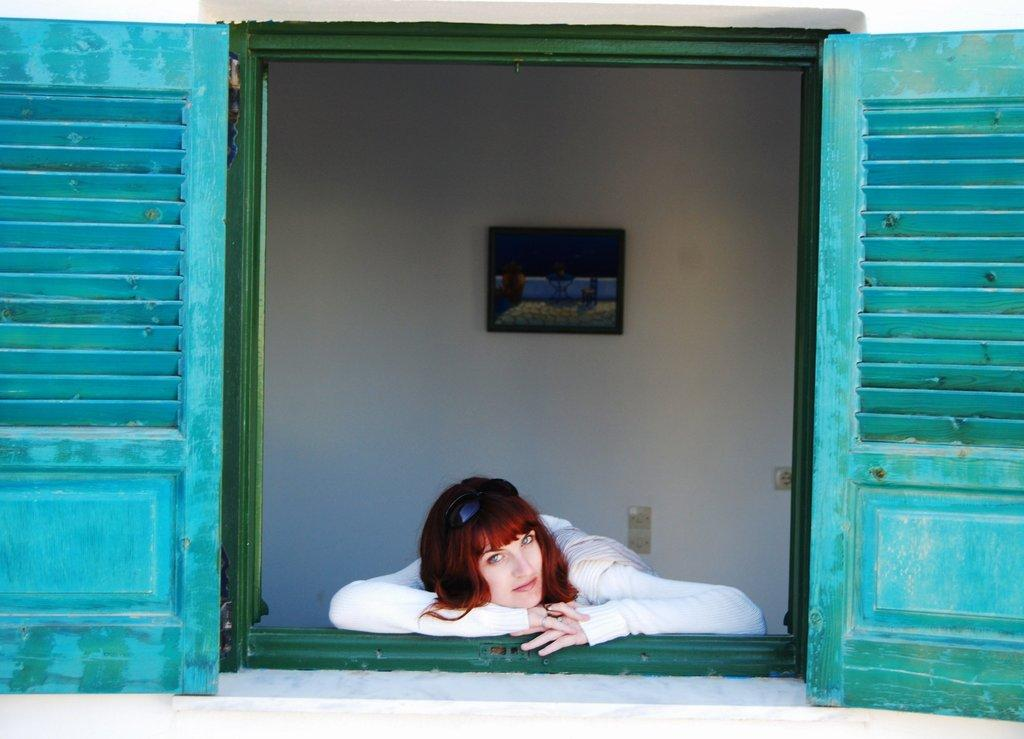What can be seen in the image that provides a view of the outside? There is a window in the image. What is the woman doing in relation to the window? A woman is laying on the window. What is visible in the background of the image? There is a wall in the background of the image. Can you describe any decorative items on the wall? There is a photo frame on the wall. What type of crayon is the woman using to draw on the door in the image? There is no door or crayon present in the image. How does the flight of birds relate to the woman laying on the window in the image? There is no mention of birds or a flight in the image; it only features a woman laying on a window and a wall with a photo frame in the background. 